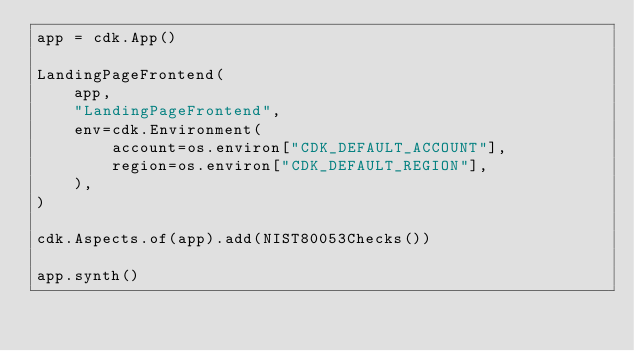Convert code to text. <code><loc_0><loc_0><loc_500><loc_500><_Python_>app = cdk.App()

LandingPageFrontend(
    app,
    "LandingPageFrontend",
    env=cdk.Environment(
        account=os.environ["CDK_DEFAULT_ACCOUNT"],
        region=os.environ["CDK_DEFAULT_REGION"],
    ),
)

cdk.Aspects.of(app).add(NIST80053Checks())

app.synth()
</code> 